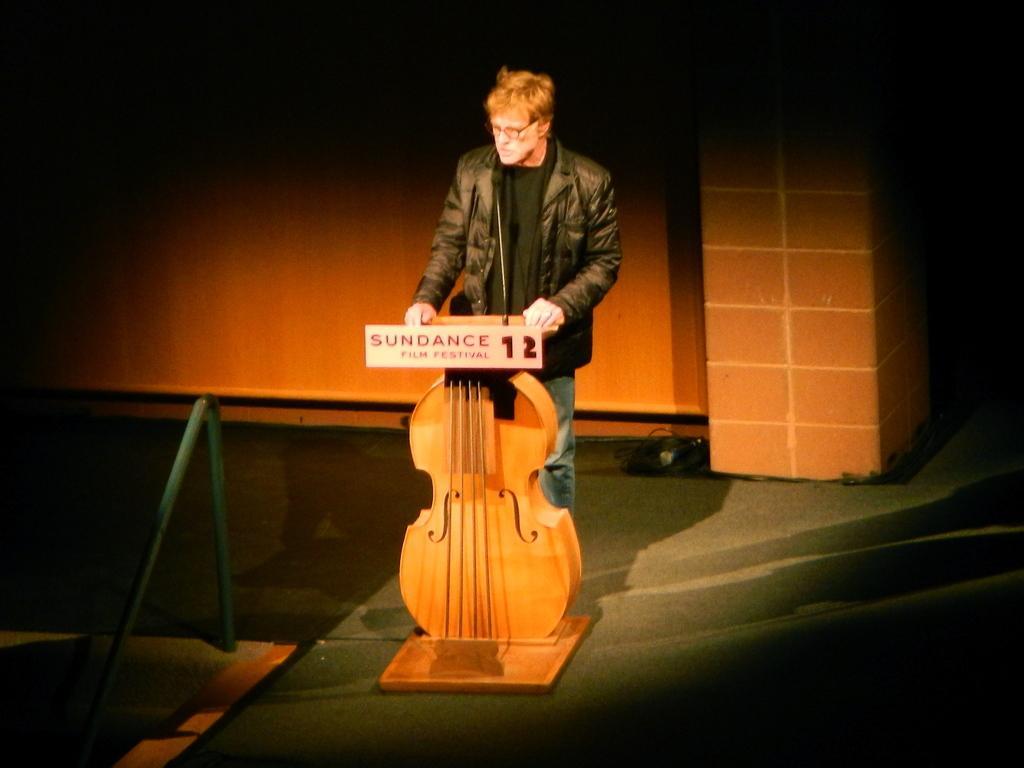In one or two sentences, can you explain what this image depicts? On the middle of the image a man wearing a black jacket is standing. In front of him there is a mic. he is standing by a violin shaped podium. in the background there is a wall. 